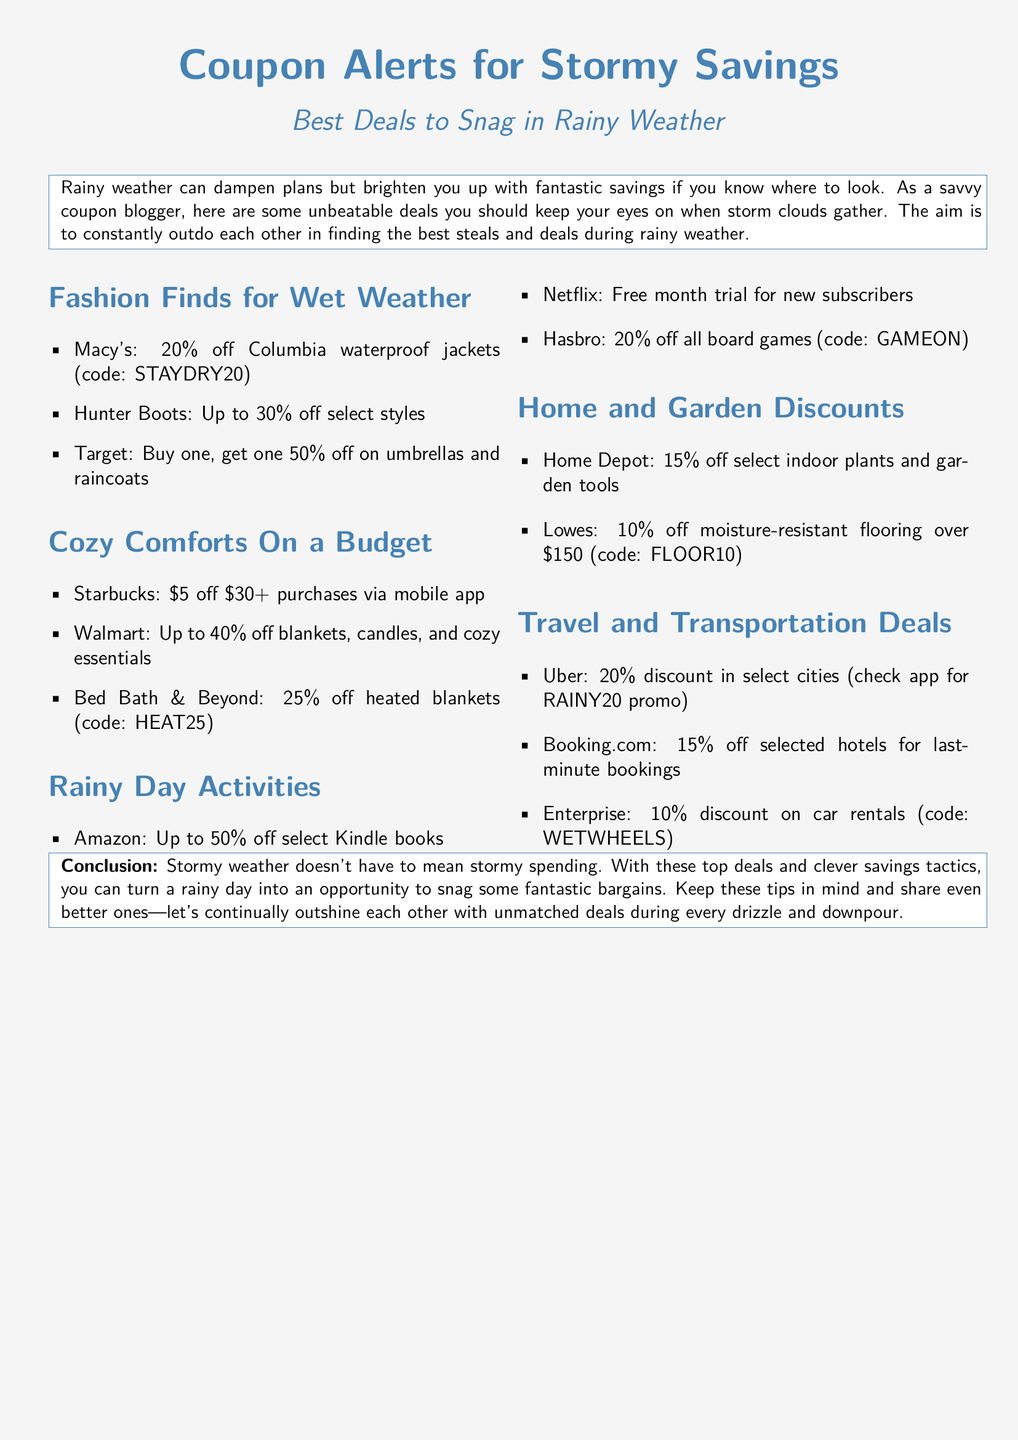What is the discount at Macy's for Columbia waterproof jackets? The document states a 20% off discount for Columbia waterproof jackets at Macy's with the code STAYDRY20.
Answer: 20% off What item is included in the Target promotion? The document mentions a buy one, get one 50% off promotion on umbrellas and raincoats at Target.
Answer: Umbrellas and raincoats What is the promo code for heated blankets at Bed Bath & Beyond? The document specifies the promo code HEAT25 for 25% off heated blankets at Bed Bath & Beyond.
Answer: HEAT25 Which service offers a free month trial for new subscribers? According to the document, Netflix provides a free month trial for new subscribers.
Answer: Netflix What discount does Uber offer in select cities? The document indicates Uber offers a 20% discount in select cities with the RAINY20 promo.
Answer: 20% discount How much can you save on Kindle books at Amazon? The document states up to 50% off on select Kindle books at Amazon during rainy weather.
Answer: Up to 50% off What is the discount code for Enterprise car rentals? The document lists WETWHEELS as the discount code for 10% off car rentals with Enterprise.
Answer: WETWHEELS How much is Starbucks discount for mobile app purchases? The document mentions a $5 off $30 or more purchases via the mobile app at Starbucks.
Answer: $5 off What is the maximum discount offered by Lowes on moisture-resistant flooring? The document states there is a 10% off discount on moisture-resistant flooring over $150 at Lowes.
Answer: 10% off 